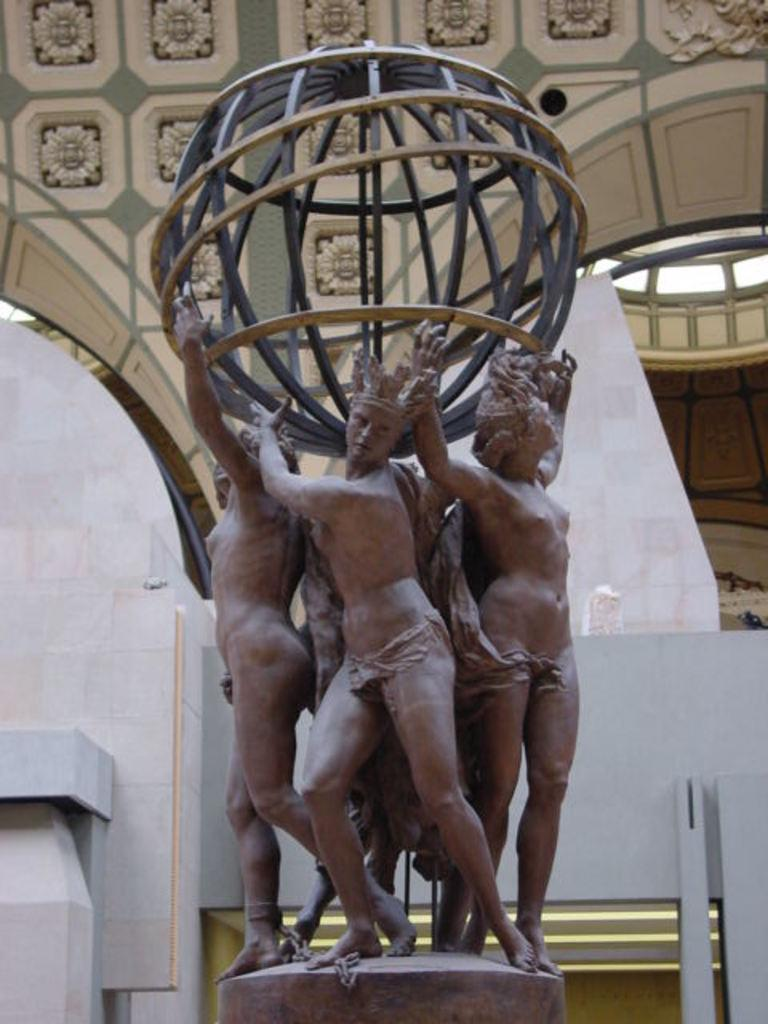What is the main subject in the foreground of the image? There is a sculpture in the foreground of the image. What architectural features can be seen in the background of the image? There are arches in the background of the image. What type of sound can be heard coming from the sculpture in the image? There is no sound coming from the sculpture in the image, as it is a static object. 